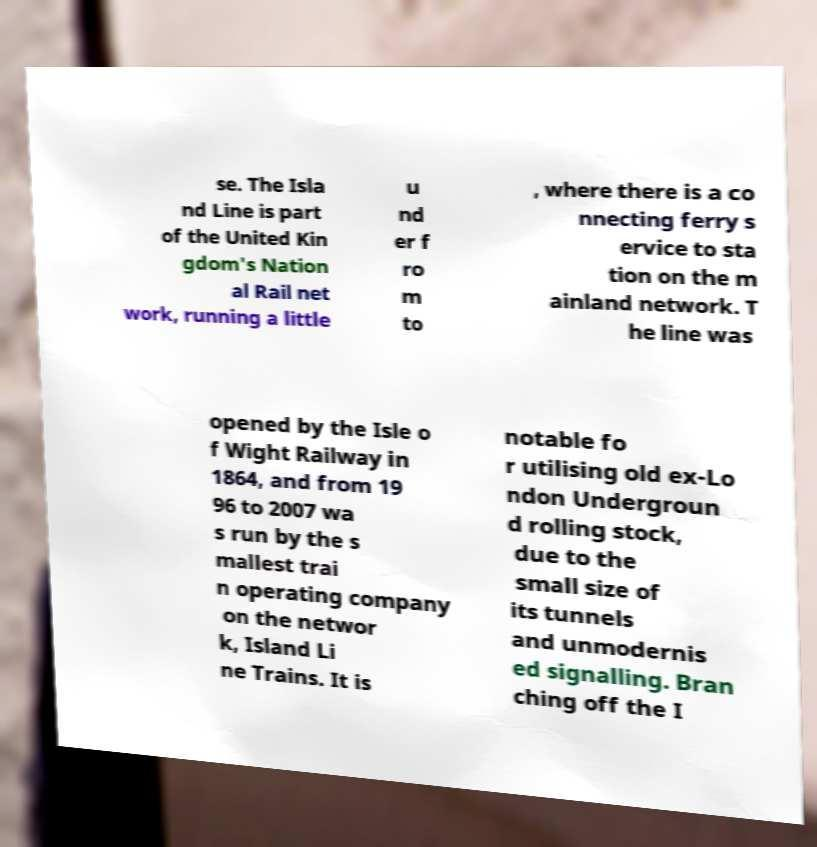Could you assist in decoding the text presented in this image and type it out clearly? se. The Isla nd Line is part of the United Kin gdom's Nation al Rail net work, running a little u nd er f ro m to , where there is a co nnecting ferry s ervice to sta tion on the m ainland network. T he line was opened by the Isle o f Wight Railway in 1864, and from 19 96 to 2007 wa s run by the s mallest trai n operating company on the networ k, Island Li ne Trains. It is notable fo r utilising old ex-Lo ndon Undergroun d rolling stock, due to the small size of its tunnels and unmodernis ed signalling. Bran ching off the I 